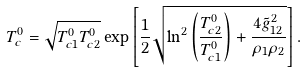Convert formula to latex. <formula><loc_0><loc_0><loc_500><loc_500>T _ { c } ^ { 0 } = \sqrt { T _ { c 1 } ^ { 0 } T _ { c 2 } ^ { 0 } } \exp \left [ { \frac { 1 } { 2 } \sqrt { \ln ^ { 2 } \left ( \frac { T _ { c 2 } ^ { 0 } } { T _ { c 1 } ^ { 0 } } \right ) + \frac { 4 \tilde { g } _ { 1 2 } ^ { 2 } } { \rho _ { 1 } \rho _ { 2 } } } } \right ] .</formula> 